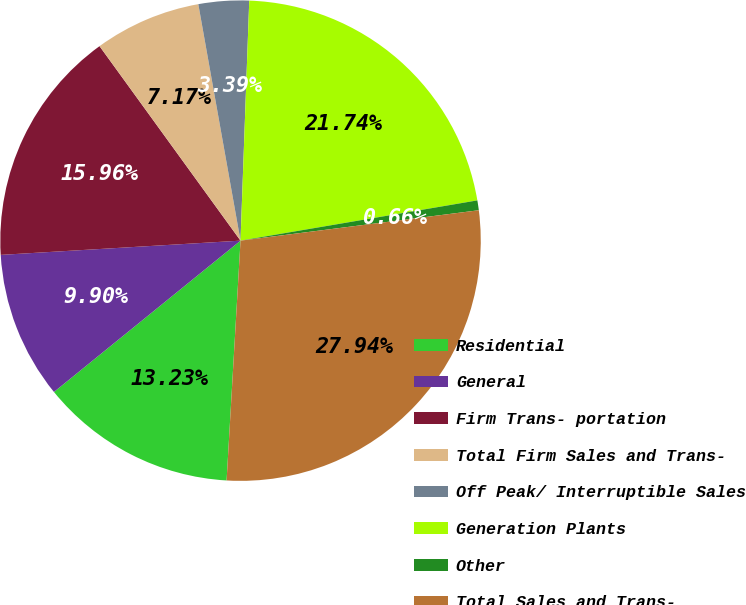Convert chart to OTSL. <chart><loc_0><loc_0><loc_500><loc_500><pie_chart><fcel>Residential<fcel>General<fcel>Firm Trans- portation<fcel>Total Firm Sales and Trans-<fcel>Off Peak/ Interruptible Sales<fcel>Generation Plants<fcel>Other<fcel>Total Sales and Trans-<nl><fcel>13.23%<fcel>9.9%<fcel>15.96%<fcel>7.17%<fcel>3.39%<fcel>21.74%<fcel>0.66%<fcel>27.94%<nl></chart> 